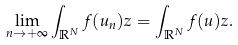Convert formula to latex. <formula><loc_0><loc_0><loc_500><loc_500>\underset { n \to + \infty } { \lim } \int _ { \mathbb { R } ^ { N } } f ( u _ { n } ) z = \int _ { \mathbb { R } ^ { N } } f ( u ) z .</formula> 